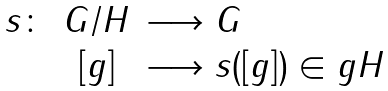Convert formula to latex. <formula><loc_0><loc_0><loc_500><loc_500>\begin{array} { r c l } s \colon & G / H & \longrightarrow G \\ & [ g ] & \longrightarrow s ( [ g ] ) \in g H \end{array}</formula> 